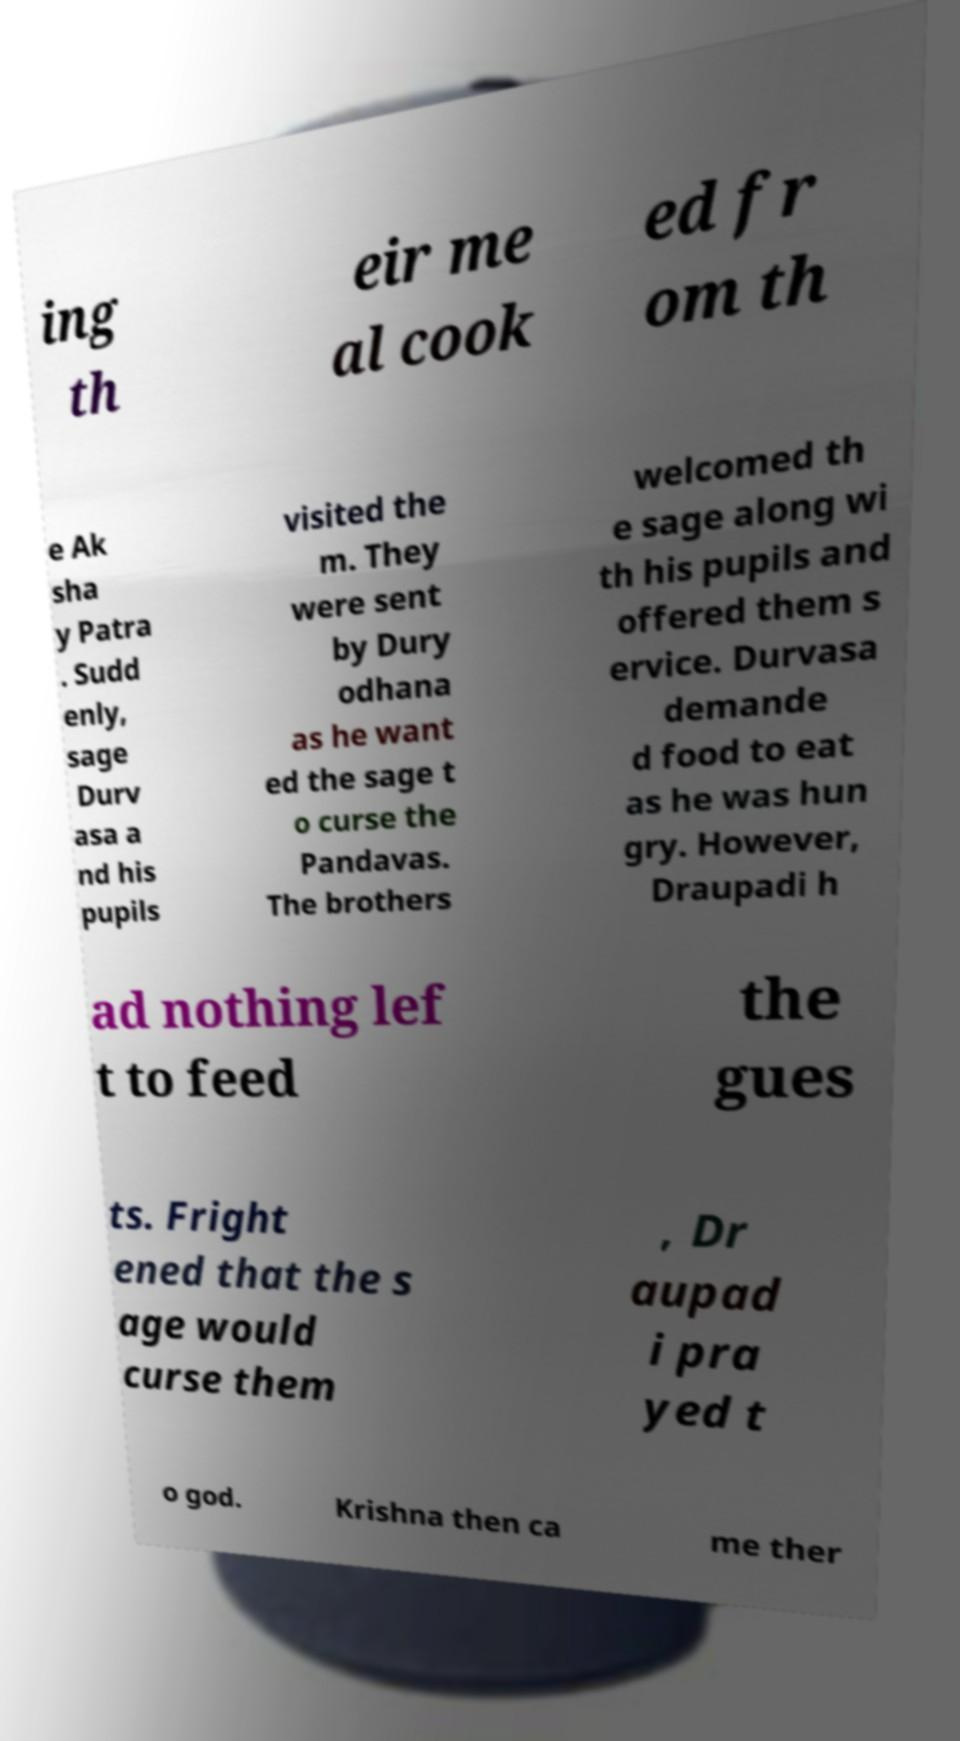Could you extract and type out the text from this image? ing th eir me al cook ed fr om th e Ak sha y Patra . Sudd enly, sage Durv asa a nd his pupils visited the m. They were sent by Dury odhana as he want ed the sage t o curse the Pandavas. The brothers welcomed th e sage along wi th his pupils and offered them s ervice. Durvasa demande d food to eat as he was hun gry. However, Draupadi h ad nothing lef t to feed the gues ts. Fright ened that the s age would curse them , Dr aupad i pra yed t o god. Krishna then ca me ther 